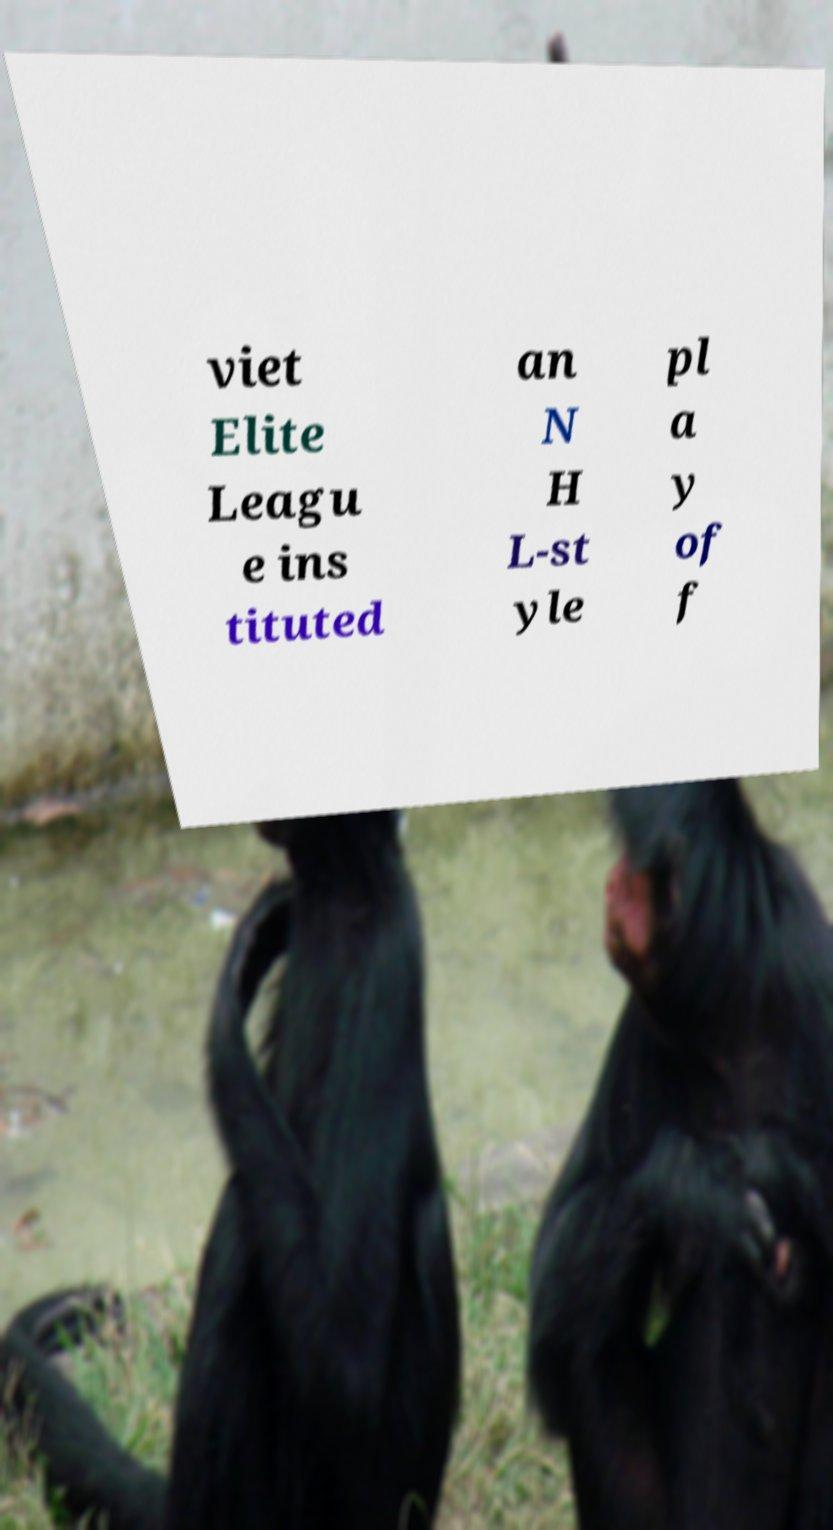Could you assist in decoding the text presented in this image and type it out clearly? viet Elite Leagu e ins tituted an N H L-st yle pl a y of f 